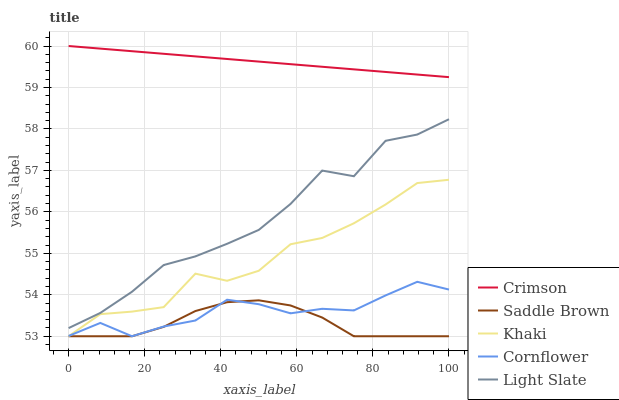Does Saddle Brown have the minimum area under the curve?
Answer yes or no. Yes. Does Crimson have the maximum area under the curve?
Answer yes or no. Yes. Does Cornflower have the minimum area under the curve?
Answer yes or no. No. Does Cornflower have the maximum area under the curve?
Answer yes or no. No. Is Crimson the smoothest?
Answer yes or no. Yes. Is Khaki the roughest?
Answer yes or no. Yes. Is Cornflower the smoothest?
Answer yes or no. No. Is Cornflower the roughest?
Answer yes or no. No. Does Light Slate have the lowest value?
Answer yes or no. No. Does Crimson have the highest value?
Answer yes or no. Yes. Does Cornflower have the highest value?
Answer yes or no. No. Is Light Slate less than Crimson?
Answer yes or no. Yes. Is Crimson greater than Saddle Brown?
Answer yes or no. Yes. Does Cornflower intersect Saddle Brown?
Answer yes or no. Yes. Is Cornflower less than Saddle Brown?
Answer yes or no. No. Is Cornflower greater than Saddle Brown?
Answer yes or no. No. Does Light Slate intersect Crimson?
Answer yes or no. No. 